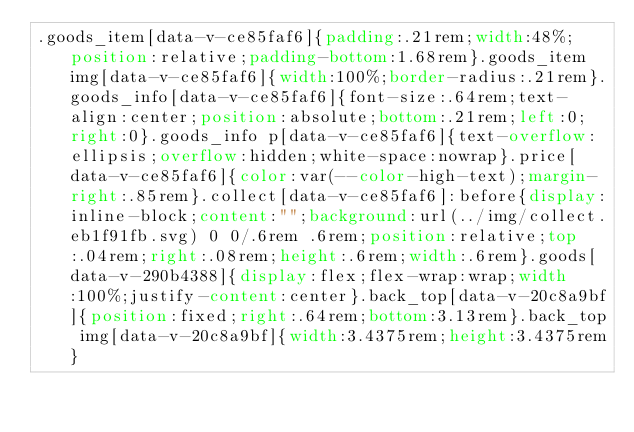<code> <loc_0><loc_0><loc_500><loc_500><_CSS_>.goods_item[data-v-ce85faf6]{padding:.21rem;width:48%;position:relative;padding-bottom:1.68rem}.goods_item img[data-v-ce85faf6]{width:100%;border-radius:.21rem}.goods_info[data-v-ce85faf6]{font-size:.64rem;text-align:center;position:absolute;bottom:.21rem;left:0;right:0}.goods_info p[data-v-ce85faf6]{text-overflow:ellipsis;overflow:hidden;white-space:nowrap}.price[data-v-ce85faf6]{color:var(--color-high-text);margin-right:.85rem}.collect[data-v-ce85faf6]:before{display:inline-block;content:"";background:url(../img/collect.eb1f91fb.svg) 0 0/.6rem .6rem;position:relative;top:.04rem;right:.08rem;height:.6rem;width:.6rem}.goods[data-v-290b4388]{display:flex;flex-wrap:wrap;width:100%;justify-content:center}.back_top[data-v-20c8a9bf]{position:fixed;right:.64rem;bottom:3.13rem}.back_top img[data-v-20c8a9bf]{width:3.4375rem;height:3.4375rem}</code> 